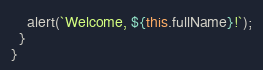Convert code to text. <code><loc_0><loc_0><loc_500><loc_500><_JavaScript_>    alert(`Welcome, ${this.fullName}!`);
  }
}</code> 